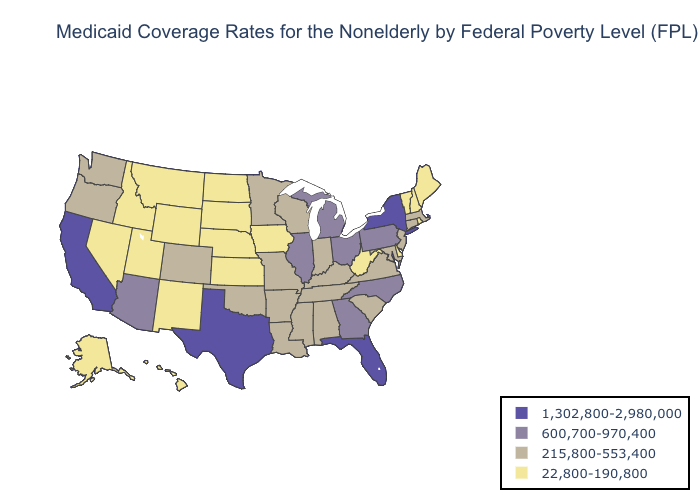Name the states that have a value in the range 1,302,800-2,980,000?
Keep it brief. California, Florida, New York, Texas. Is the legend a continuous bar?
Write a very short answer. No. Does Alaska have the same value as Oklahoma?
Short answer required. No. What is the highest value in the South ?
Quick response, please. 1,302,800-2,980,000. What is the highest value in the West ?
Give a very brief answer. 1,302,800-2,980,000. How many symbols are there in the legend?
Short answer required. 4. Name the states that have a value in the range 22,800-190,800?
Concise answer only. Alaska, Delaware, Hawaii, Idaho, Iowa, Kansas, Maine, Montana, Nebraska, Nevada, New Hampshire, New Mexico, North Dakota, Rhode Island, South Dakota, Utah, Vermont, West Virginia, Wyoming. Which states hav the highest value in the Northeast?
Concise answer only. New York. Does New Mexico have the lowest value in the USA?
Short answer required. Yes. Does Minnesota have a higher value than Illinois?
Short answer required. No. Which states have the lowest value in the USA?
Concise answer only. Alaska, Delaware, Hawaii, Idaho, Iowa, Kansas, Maine, Montana, Nebraska, Nevada, New Hampshire, New Mexico, North Dakota, Rhode Island, South Dakota, Utah, Vermont, West Virginia, Wyoming. Name the states that have a value in the range 22,800-190,800?
Answer briefly. Alaska, Delaware, Hawaii, Idaho, Iowa, Kansas, Maine, Montana, Nebraska, Nevada, New Hampshire, New Mexico, North Dakota, Rhode Island, South Dakota, Utah, Vermont, West Virginia, Wyoming. Name the states that have a value in the range 1,302,800-2,980,000?
Keep it brief. California, Florida, New York, Texas. What is the lowest value in the USA?
Write a very short answer. 22,800-190,800. What is the highest value in states that border Pennsylvania?
Quick response, please. 1,302,800-2,980,000. 